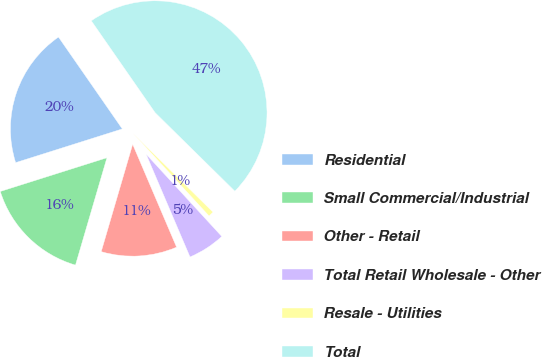<chart> <loc_0><loc_0><loc_500><loc_500><pie_chart><fcel>Residential<fcel>Small Commercial/Industrial<fcel>Other - Retail<fcel>Total Retail Wholesale - Other<fcel>Resale - Utilities<fcel>Total<nl><fcel>20.21%<fcel>15.59%<fcel>10.96%<fcel>5.41%<fcel>0.79%<fcel>47.04%<nl></chart> 